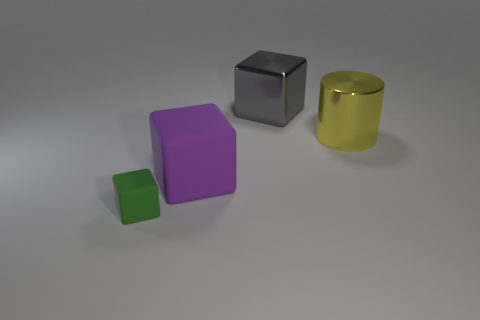Subtract all big shiny cubes. How many cubes are left? 2 Subtract all purple blocks. How many blocks are left? 2 Add 3 gray metallic objects. How many objects exist? 7 Subtract all red blocks. Subtract all cyan cylinders. How many blocks are left? 3 Subtract all yellow metallic cylinders. Subtract all brown spheres. How many objects are left? 3 Add 1 purple things. How many purple things are left? 2 Add 1 matte cubes. How many matte cubes exist? 3 Subtract 0 cyan cylinders. How many objects are left? 4 Subtract all blocks. How many objects are left? 1 